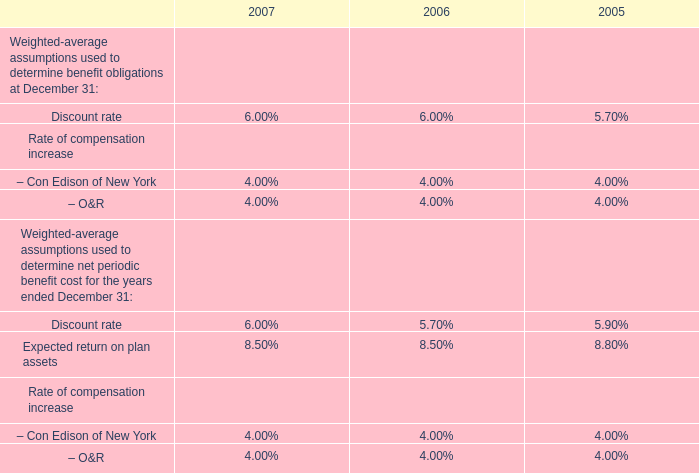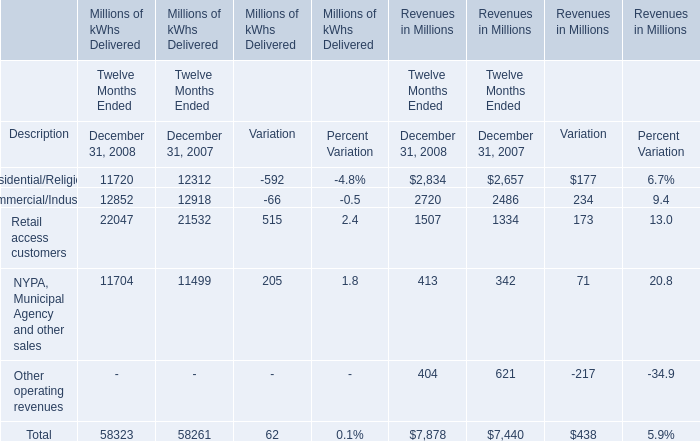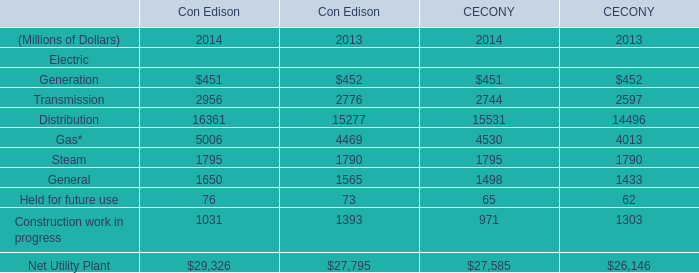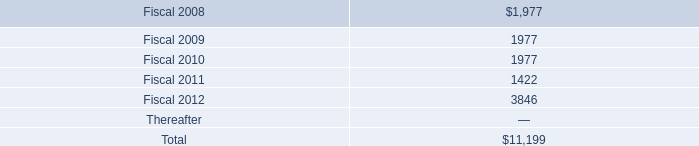what is the sum of future debt payments for the next three years? 
Computations: ((1977 + 1977) + 1977)
Answer: 5931.0. 